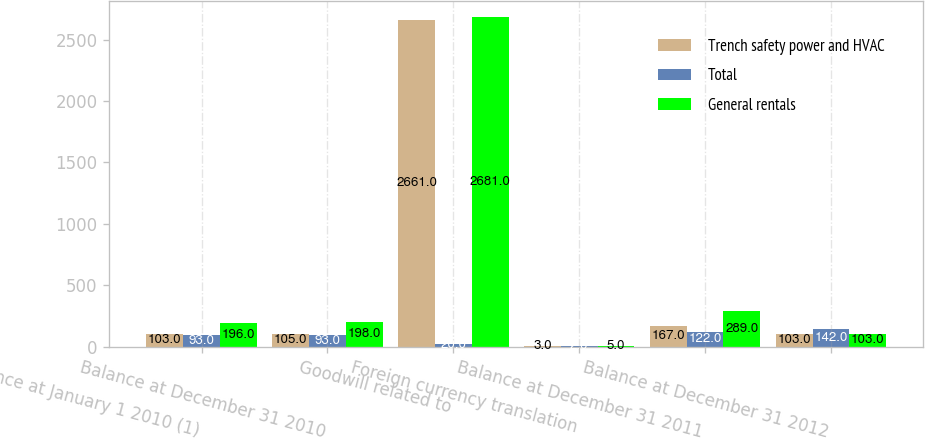Convert chart. <chart><loc_0><loc_0><loc_500><loc_500><stacked_bar_chart><ecel><fcel>Balance at January 1 2010 (1)<fcel>Balance at December 31 2010<fcel>Goodwill related to<fcel>Foreign currency translation<fcel>Balance at December 31 2011<fcel>Balance at December 31 2012<nl><fcel>Trench safety power and HVAC<fcel>103<fcel>105<fcel>2661<fcel>3<fcel>167<fcel>103<nl><fcel>Total<fcel>93<fcel>93<fcel>20<fcel>2<fcel>122<fcel>142<nl><fcel>General rentals<fcel>196<fcel>198<fcel>2681<fcel>5<fcel>289<fcel>103<nl></chart> 